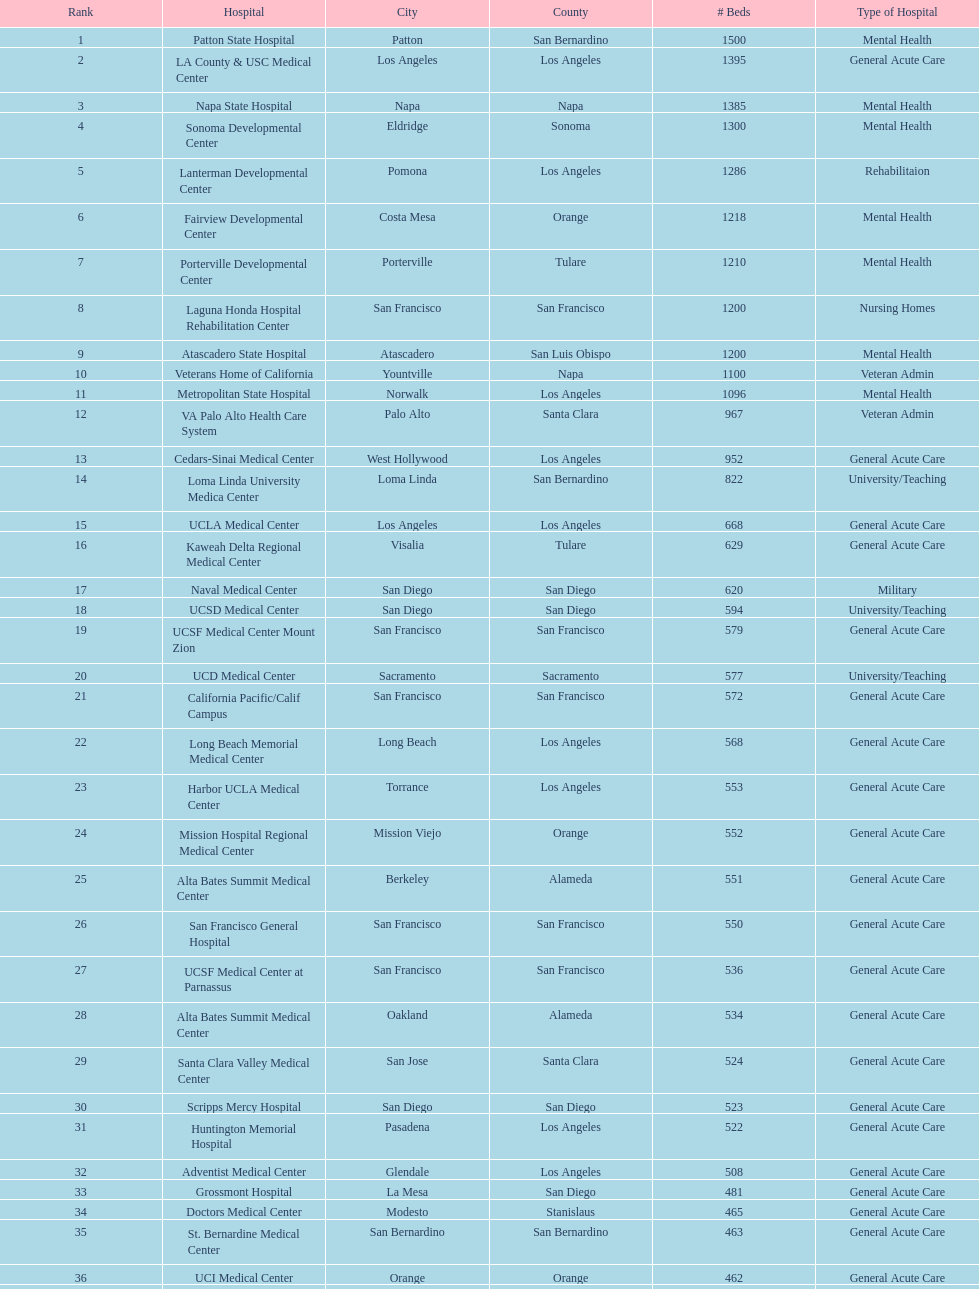How many hospitals possess 600 or more beds? 17. 